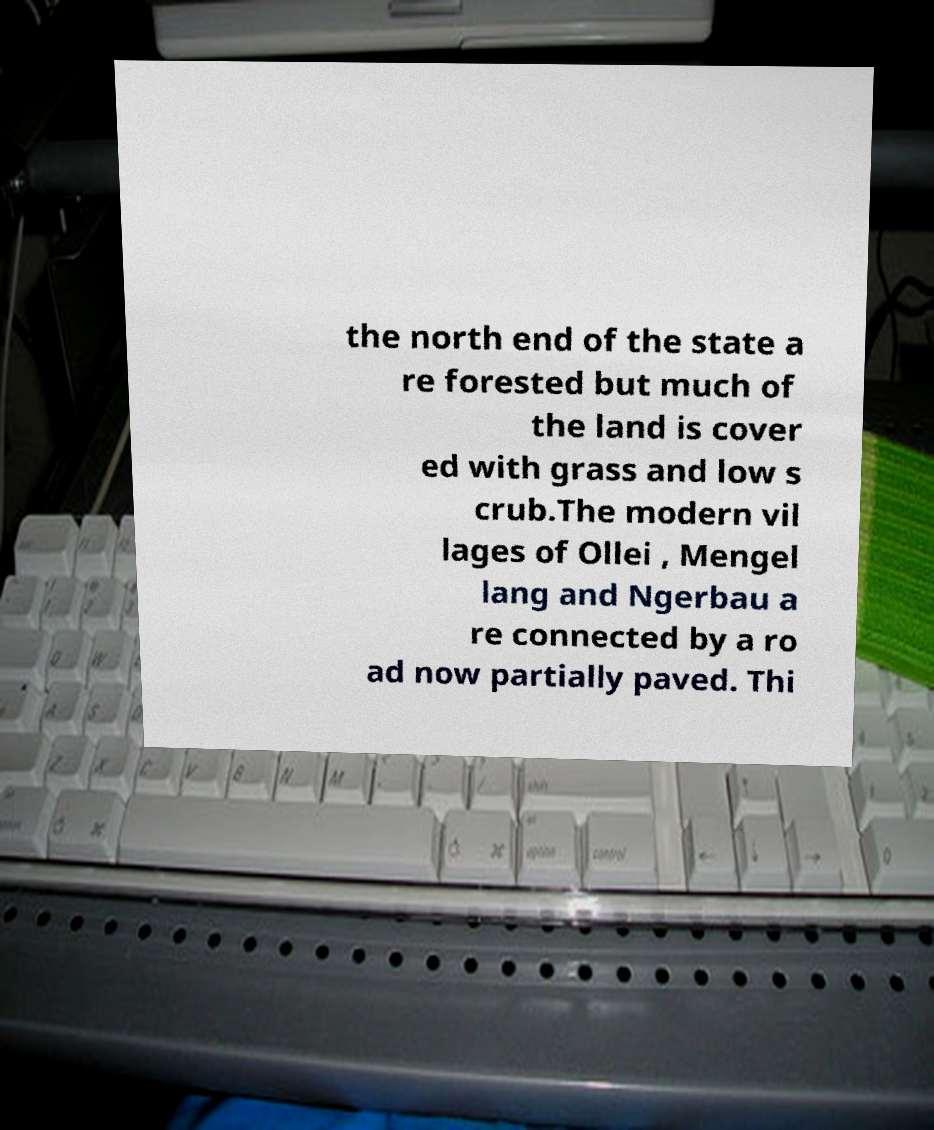Could you assist in decoding the text presented in this image and type it out clearly? the north end of the state a re forested but much of the land is cover ed with grass and low s crub.The modern vil lages of Ollei , Mengel lang and Ngerbau a re connected by a ro ad now partially paved. Thi 